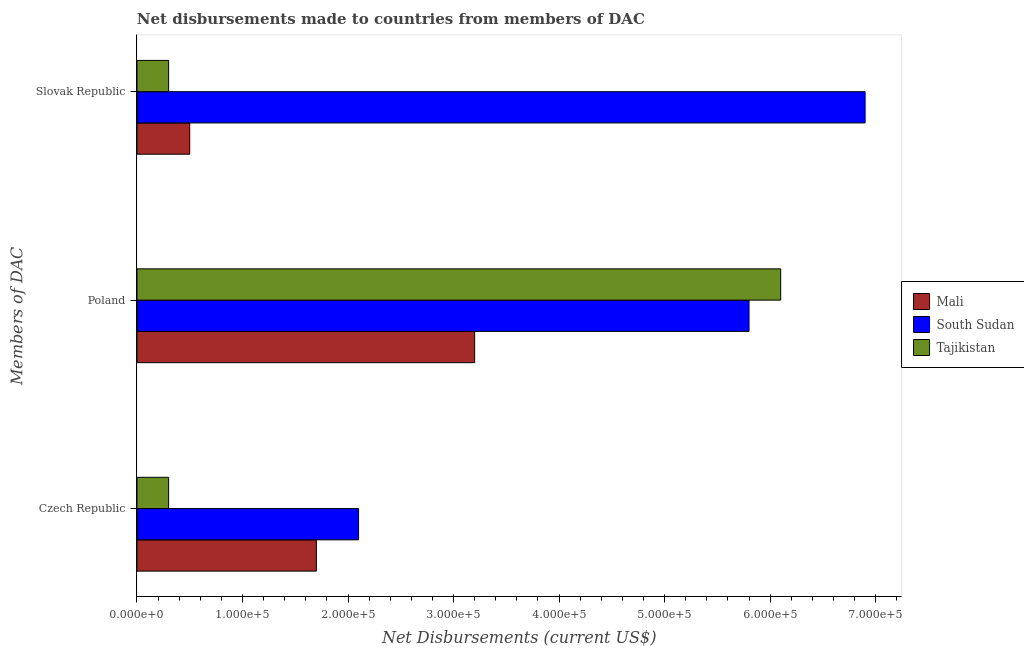How many groups of bars are there?
Ensure brevity in your answer.  3. Are the number of bars per tick equal to the number of legend labels?
Provide a short and direct response. Yes. What is the net disbursements made by czech republic in Mali?
Your answer should be very brief. 1.70e+05. Across all countries, what is the maximum net disbursements made by poland?
Make the answer very short. 6.10e+05. Across all countries, what is the minimum net disbursements made by poland?
Provide a succinct answer. 3.20e+05. In which country was the net disbursements made by czech republic maximum?
Provide a short and direct response. South Sudan. In which country was the net disbursements made by czech republic minimum?
Your answer should be compact. Tajikistan. What is the total net disbursements made by poland in the graph?
Provide a succinct answer. 1.51e+06. What is the difference between the net disbursements made by poland in Tajikistan and that in Mali?
Keep it short and to the point. 2.90e+05. What is the difference between the net disbursements made by poland in Tajikistan and the net disbursements made by czech republic in South Sudan?
Provide a short and direct response. 4.00e+05. What is the average net disbursements made by poland per country?
Offer a terse response. 5.03e+05. What is the difference between the net disbursements made by czech republic and net disbursements made by poland in Tajikistan?
Ensure brevity in your answer.  -5.80e+05. What is the ratio of the net disbursements made by slovak republic in South Sudan to that in Mali?
Offer a terse response. 13.8. Is the net disbursements made by slovak republic in South Sudan less than that in Tajikistan?
Your answer should be compact. No. Is the difference between the net disbursements made by slovak republic in Tajikistan and Mali greater than the difference between the net disbursements made by poland in Tajikistan and Mali?
Offer a terse response. No. What is the difference between the highest and the second highest net disbursements made by slovak republic?
Give a very brief answer. 6.40e+05. What is the difference between the highest and the lowest net disbursements made by poland?
Offer a terse response. 2.90e+05. What does the 3rd bar from the top in Czech Republic represents?
Offer a terse response. Mali. What does the 2nd bar from the bottom in Poland represents?
Your answer should be very brief. South Sudan. Is it the case that in every country, the sum of the net disbursements made by czech republic and net disbursements made by poland is greater than the net disbursements made by slovak republic?
Offer a very short reply. Yes. Are all the bars in the graph horizontal?
Keep it short and to the point. Yes. Are the values on the major ticks of X-axis written in scientific E-notation?
Offer a terse response. Yes. How are the legend labels stacked?
Offer a very short reply. Vertical. What is the title of the graph?
Ensure brevity in your answer.  Net disbursements made to countries from members of DAC. Does "Uganda" appear as one of the legend labels in the graph?
Offer a terse response. No. What is the label or title of the X-axis?
Give a very brief answer. Net Disbursements (current US$). What is the label or title of the Y-axis?
Your answer should be very brief. Members of DAC. What is the Net Disbursements (current US$) of South Sudan in Czech Republic?
Offer a very short reply. 2.10e+05. What is the Net Disbursements (current US$) of Mali in Poland?
Provide a short and direct response. 3.20e+05. What is the Net Disbursements (current US$) of South Sudan in Poland?
Ensure brevity in your answer.  5.80e+05. What is the Net Disbursements (current US$) of Mali in Slovak Republic?
Make the answer very short. 5.00e+04. What is the Net Disbursements (current US$) in South Sudan in Slovak Republic?
Make the answer very short. 6.90e+05. Across all Members of DAC, what is the maximum Net Disbursements (current US$) of South Sudan?
Your answer should be very brief. 6.90e+05. Across all Members of DAC, what is the minimum Net Disbursements (current US$) in Mali?
Your response must be concise. 5.00e+04. Across all Members of DAC, what is the minimum Net Disbursements (current US$) of South Sudan?
Provide a short and direct response. 2.10e+05. Across all Members of DAC, what is the minimum Net Disbursements (current US$) of Tajikistan?
Your response must be concise. 3.00e+04. What is the total Net Disbursements (current US$) of Mali in the graph?
Give a very brief answer. 5.40e+05. What is the total Net Disbursements (current US$) in South Sudan in the graph?
Ensure brevity in your answer.  1.48e+06. What is the total Net Disbursements (current US$) in Tajikistan in the graph?
Make the answer very short. 6.70e+05. What is the difference between the Net Disbursements (current US$) of Mali in Czech Republic and that in Poland?
Give a very brief answer. -1.50e+05. What is the difference between the Net Disbursements (current US$) in South Sudan in Czech Republic and that in Poland?
Your answer should be very brief. -3.70e+05. What is the difference between the Net Disbursements (current US$) in Tajikistan in Czech Republic and that in Poland?
Keep it short and to the point. -5.80e+05. What is the difference between the Net Disbursements (current US$) of South Sudan in Czech Republic and that in Slovak Republic?
Provide a short and direct response. -4.80e+05. What is the difference between the Net Disbursements (current US$) of Tajikistan in Czech Republic and that in Slovak Republic?
Provide a short and direct response. 0. What is the difference between the Net Disbursements (current US$) of Tajikistan in Poland and that in Slovak Republic?
Keep it short and to the point. 5.80e+05. What is the difference between the Net Disbursements (current US$) in Mali in Czech Republic and the Net Disbursements (current US$) in South Sudan in Poland?
Keep it short and to the point. -4.10e+05. What is the difference between the Net Disbursements (current US$) in Mali in Czech Republic and the Net Disbursements (current US$) in Tajikistan in Poland?
Provide a succinct answer. -4.40e+05. What is the difference between the Net Disbursements (current US$) in South Sudan in Czech Republic and the Net Disbursements (current US$) in Tajikistan in Poland?
Offer a terse response. -4.00e+05. What is the difference between the Net Disbursements (current US$) in Mali in Czech Republic and the Net Disbursements (current US$) in South Sudan in Slovak Republic?
Keep it short and to the point. -5.20e+05. What is the difference between the Net Disbursements (current US$) in Mali in Poland and the Net Disbursements (current US$) in South Sudan in Slovak Republic?
Provide a short and direct response. -3.70e+05. What is the difference between the Net Disbursements (current US$) in Mali in Poland and the Net Disbursements (current US$) in Tajikistan in Slovak Republic?
Offer a very short reply. 2.90e+05. What is the average Net Disbursements (current US$) of South Sudan per Members of DAC?
Offer a terse response. 4.93e+05. What is the average Net Disbursements (current US$) of Tajikistan per Members of DAC?
Offer a very short reply. 2.23e+05. What is the difference between the Net Disbursements (current US$) in Mali and Net Disbursements (current US$) in South Sudan in Czech Republic?
Your response must be concise. -4.00e+04. What is the difference between the Net Disbursements (current US$) in Mali and Net Disbursements (current US$) in Tajikistan in Czech Republic?
Provide a succinct answer. 1.40e+05. What is the difference between the Net Disbursements (current US$) in Mali and Net Disbursements (current US$) in South Sudan in Poland?
Make the answer very short. -2.60e+05. What is the difference between the Net Disbursements (current US$) of Mali and Net Disbursements (current US$) of Tajikistan in Poland?
Your answer should be compact. -2.90e+05. What is the difference between the Net Disbursements (current US$) of South Sudan and Net Disbursements (current US$) of Tajikistan in Poland?
Ensure brevity in your answer.  -3.00e+04. What is the difference between the Net Disbursements (current US$) in Mali and Net Disbursements (current US$) in South Sudan in Slovak Republic?
Offer a very short reply. -6.40e+05. What is the difference between the Net Disbursements (current US$) of Mali and Net Disbursements (current US$) of Tajikistan in Slovak Republic?
Your answer should be very brief. 2.00e+04. What is the ratio of the Net Disbursements (current US$) of Mali in Czech Republic to that in Poland?
Give a very brief answer. 0.53. What is the ratio of the Net Disbursements (current US$) of South Sudan in Czech Republic to that in Poland?
Make the answer very short. 0.36. What is the ratio of the Net Disbursements (current US$) of Tajikistan in Czech Republic to that in Poland?
Provide a succinct answer. 0.05. What is the ratio of the Net Disbursements (current US$) of South Sudan in Czech Republic to that in Slovak Republic?
Offer a terse response. 0.3. What is the ratio of the Net Disbursements (current US$) of Tajikistan in Czech Republic to that in Slovak Republic?
Provide a succinct answer. 1. What is the ratio of the Net Disbursements (current US$) in Mali in Poland to that in Slovak Republic?
Your response must be concise. 6.4. What is the ratio of the Net Disbursements (current US$) in South Sudan in Poland to that in Slovak Republic?
Make the answer very short. 0.84. What is the ratio of the Net Disbursements (current US$) in Tajikistan in Poland to that in Slovak Republic?
Give a very brief answer. 20.33. What is the difference between the highest and the second highest Net Disbursements (current US$) of Mali?
Your response must be concise. 1.50e+05. What is the difference between the highest and the second highest Net Disbursements (current US$) of Tajikistan?
Your response must be concise. 5.80e+05. What is the difference between the highest and the lowest Net Disbursements (current US$) in Mali?
Provide a short and direct response. 2.70e+05. What is the difference between the highest and the lowest Net Disbursements (current US$) in Tajikistan?
Ensure brevity in your answer.  5.80e+05. 